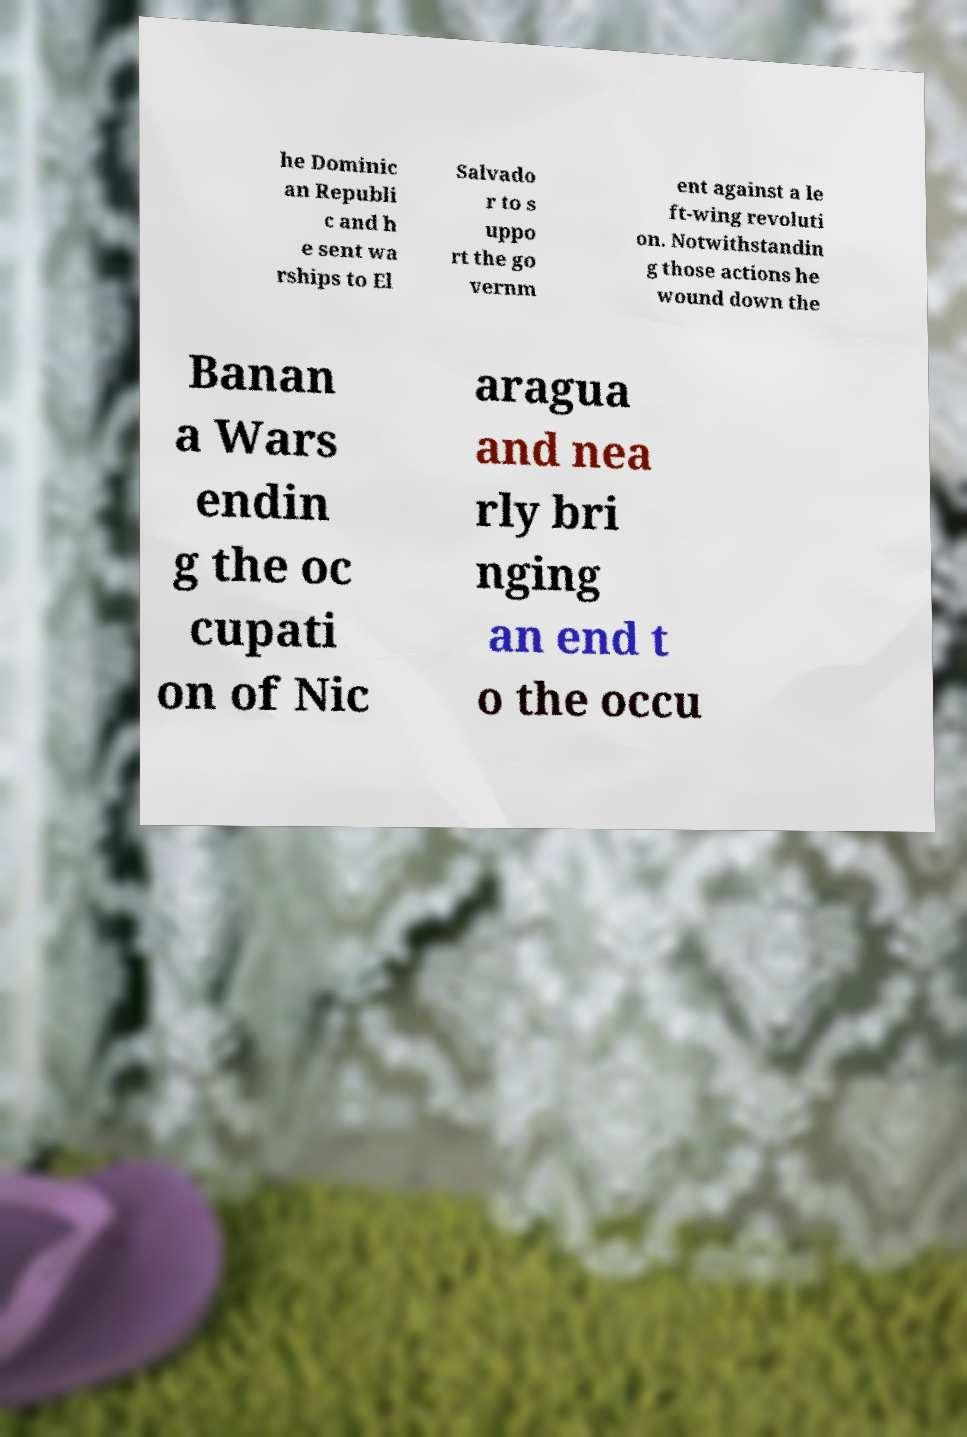Could you extract and type out the text from this image? he Dominic an Republi c and h e sent wa rships to El Salvado r to s uppo rt the go vernm ent against a le ft-wing revoluti on. Notwithstandin g those actions he wound down the Banan a Wars endin g the oc cupati on of Nic aragua and nea rly bri nging an end t o the occu 